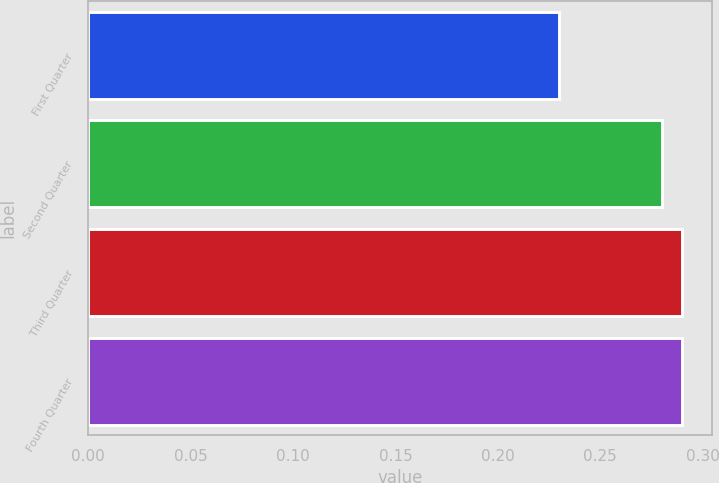Convert chart to OTSL. <chart><loc_0><loc_0><loc_500><loc_500><bar_chart><fcel>First Quarter<fcel>Second Quarter<fcel>Third Quarter<fcel>Fourth Quarter<nl><fcel>0.23<fcel>0.28<fcel>0.29<fcel>0.29<nl></chart> 